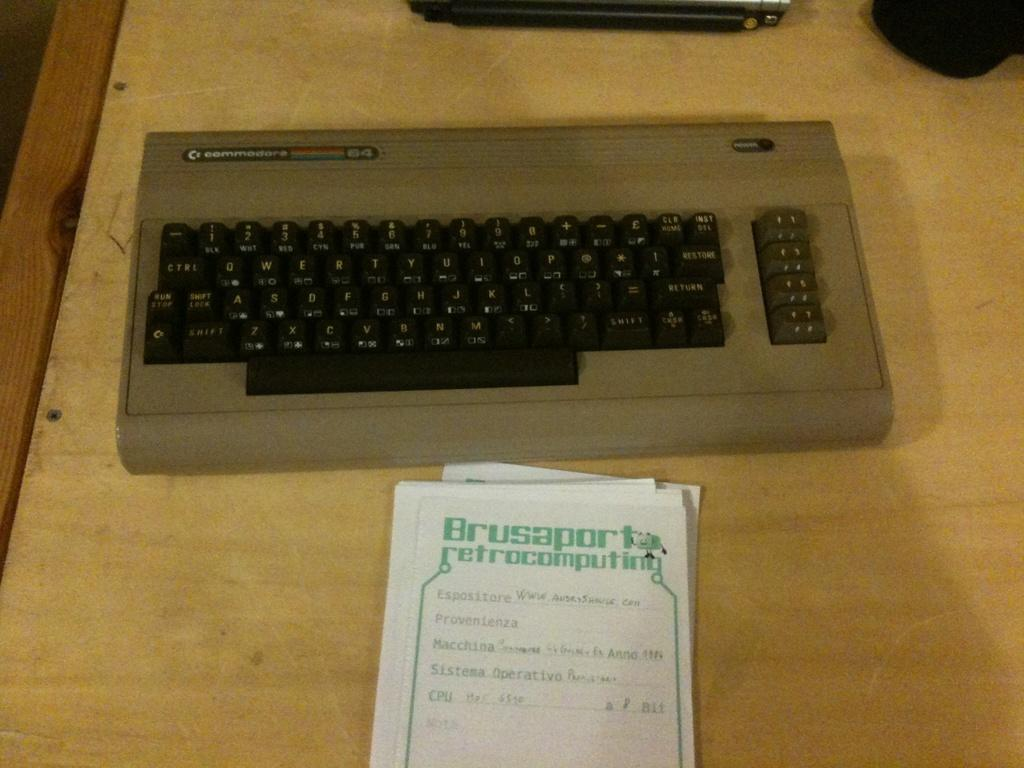Provide a one-sentence caption for the provided image. An old-fashioned keyboard with a notepad that says Brusaporta retrocomputing. 